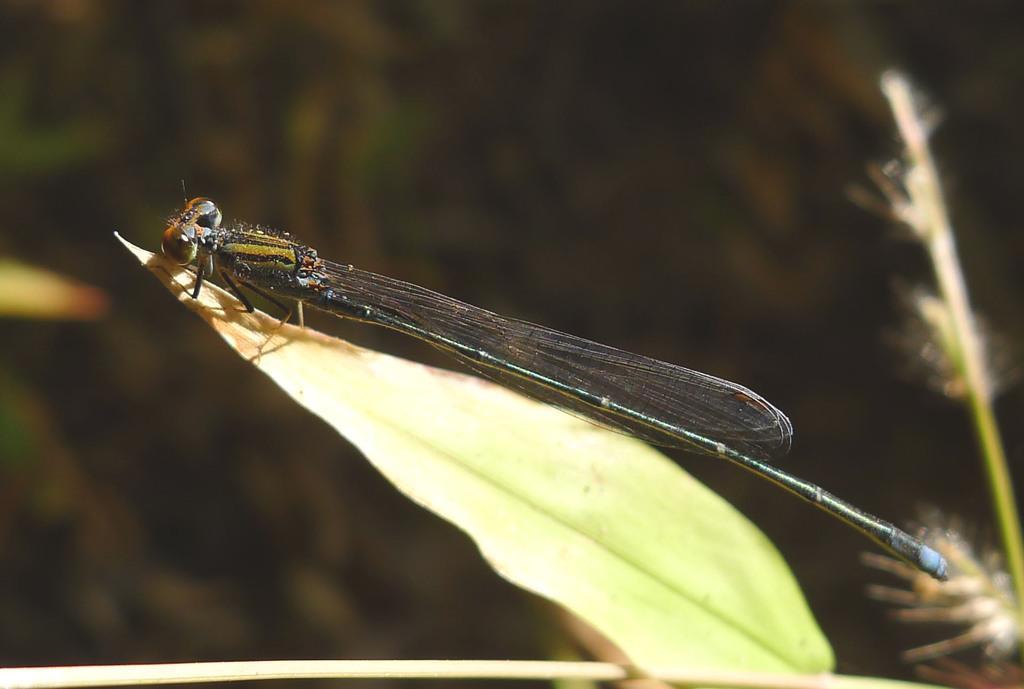Please provide a concise description of this image. In this image there is an insect. 